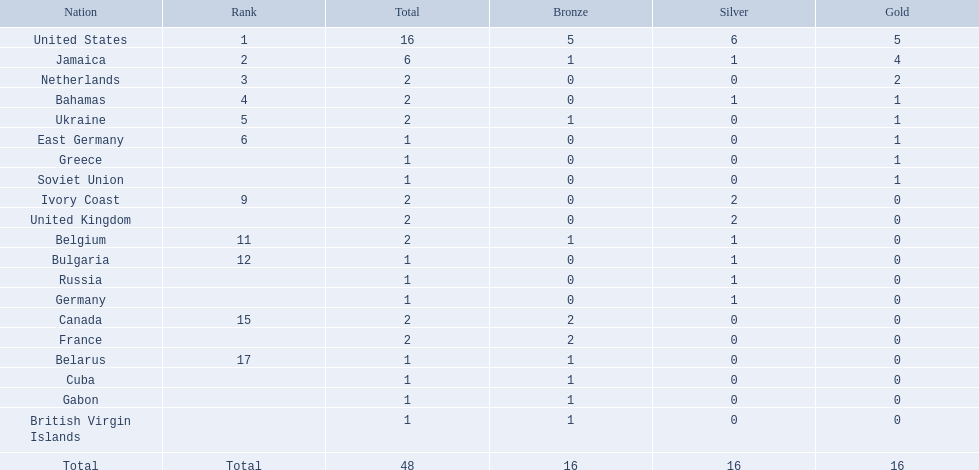What countries competed? United States, Jamaica, Netherlands, Bahamas, Ukraine, East Germany, Greece, Soviet Union, Ivory Coast, United Kingdom, Belgium, Bulgaria, Russia, Germany, Canada, France, Belarus, Cuba, Gabon, British Virgin Islands. Which countries won gold medals? United States, Jamaica, Netherlands, Bahamas, Ukraine, East Germany, Greece, Soviet Union. Which country had the second most medals? Jamaica. 